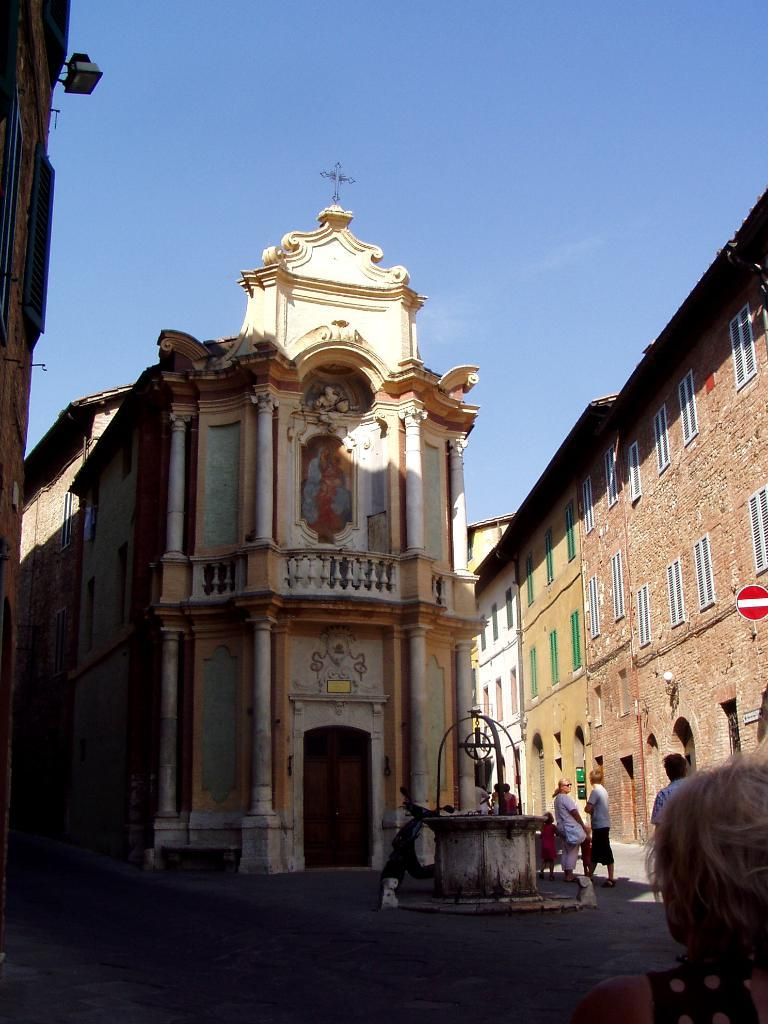What type of structures can be seen in the image? There are buildings in the image. Are there any living beings present in the image? Yes, there are people in the image. What mode of transportation is visible in the image? There is a motorbike in the image. What is a notable feature of the landscape in the image? There is a well in the image. What are the buildings in the image equipped with? The buildings in the image have windows and doors. What is the color of the sky in the image? The sky is blue in color. Is there any signage present in the image? Yes, there is a signboard in the image. Can you tell me how many times the people in the image kiss each other? There is no indication of any kissing in the image. What type of boundary is present in the image? There is no mention of a boundary in the image. 